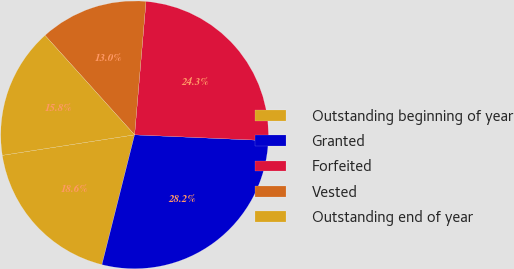<chart> <loc_0><loc_0><loc_500><loc_500><pie_chart><fcel>Outstanding beginning of year<fcel>Granted<fcel>Forfeited<fcel>Vested<fcel>Outstanding end of year<nl><fcel>18.63%<fcel>28.23%<fcel>24.34%<fcel>13.03%<fcel>15.78%<nl></chart> 